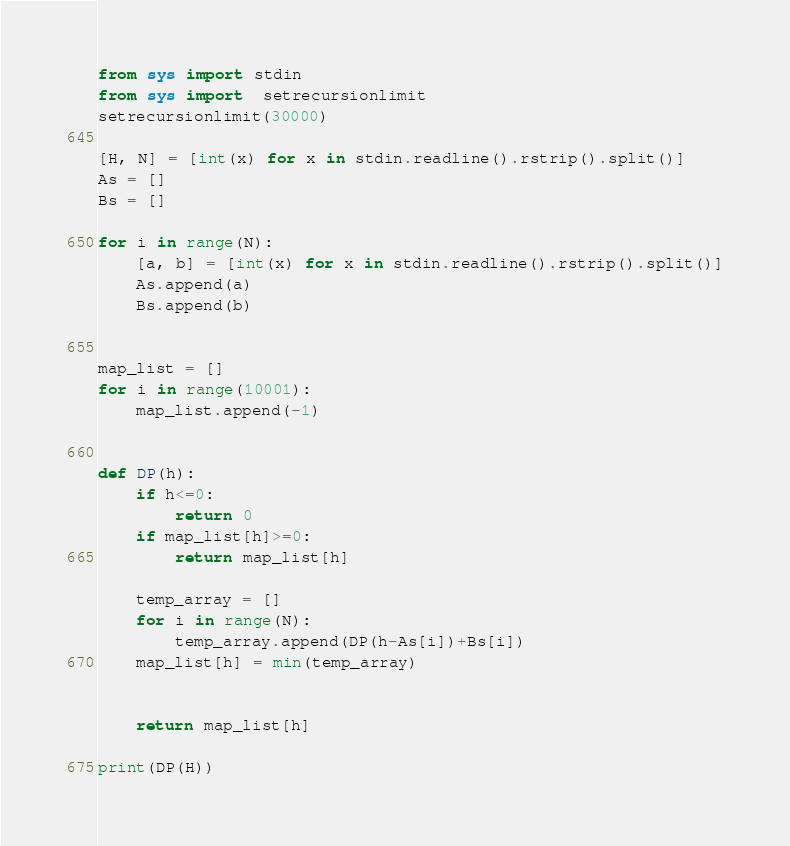<code> <loc_0><loc_0><loc_500><loc_500><_Python_>from sys import stdin
from sys import  setrecursionlimit
setrecursionlimit(30000)

[H, N] = [int(x) for x in stdin.readline().rstrip().split()]
As = []
Bs = []

for i in range(N):
    [a, b] = [int(x) for x in stdin.readline().rstrip().split()]
    As.append(a)
    Bs.append(b)


map_list = []
for i in range(10001):
    map_list.append(-1)


def DP(h):
    if h<=0:
        return 0
    if map_list[h]>=0:
        return map_list[h]
    
    temp_array = []
    for i in range(N):
        temp_array.append(DP(h-As[i])+Bs[i])
    map_list[h] = min(temp_array)
    

    return map_list[h]

print(DP(H))    

</code> 